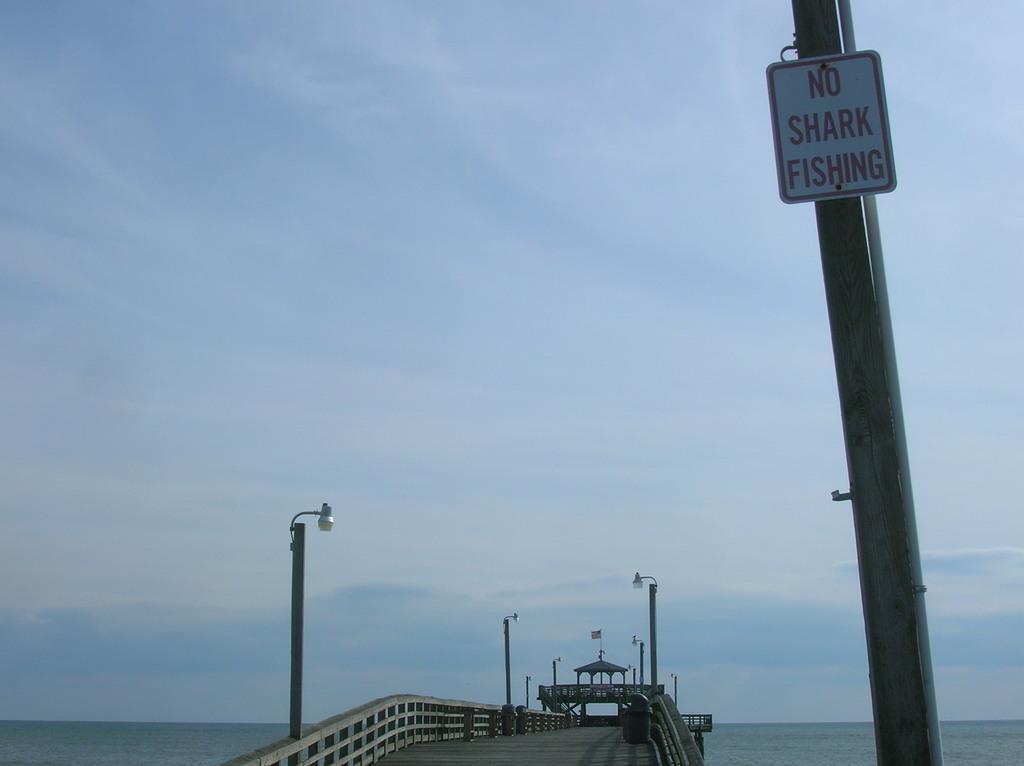How would you summarize this image in a sentence or two? This image is taken outdoors. At the top of the image there is a sky with clouds. At the bottom of the image there is a sea and there is a bridge with railings, walls, a flag and a few poles with lights. On the right side of the image there is a pole with a signboard. 